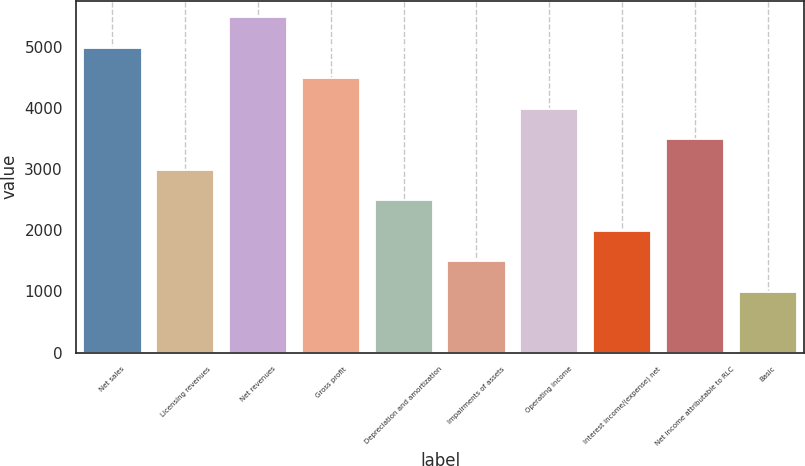Convert chart. <chart><loc_0><loc_0><loc_500><loc_500><bar_chart><fcel>Net sales<fcel>Licensing revenues<fcel>Net revenues<fcel>Gross profit<fcel>Depreciation and amortization<fcel>Impairments of assets<fcel>Operating income<fcel>Interest income/(expense) net<fcel>Net income attributable to RLC<fcel>Basic<nl><fcel>4978.9<fcel>2987.46<fcel>5476.76<fcel>4481.04<fcel>2489.6<fcel>1493.88<fcel>3983.18<fcel>1991.74<fcel>3485.32<fcel>996.02<nl></chart> 